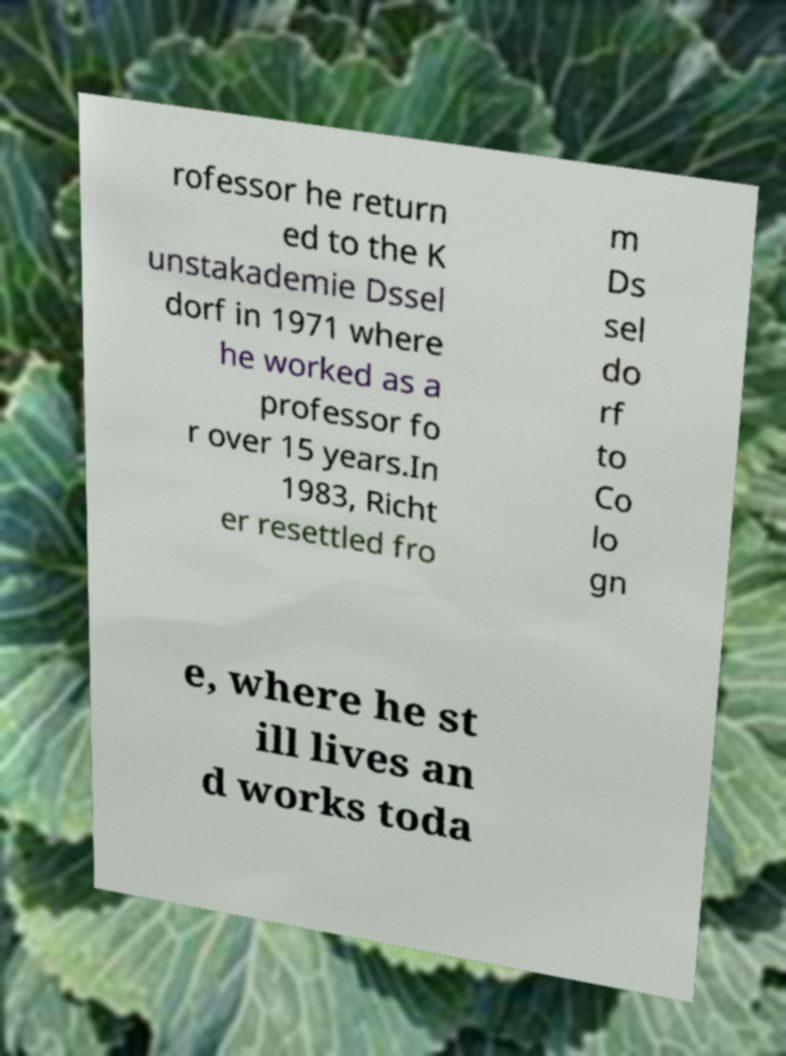For documentation purposes, I need the text within this image transcribed. Could you provide that? rofessor he return ed to the K unstakademie Dssel dorf in 1971 where he worked as a professor fo r over 15 years.In 1983, Richt er resettled fro m Ds sel do rf to Co lo gn e, where he st ill lives an d works toda 